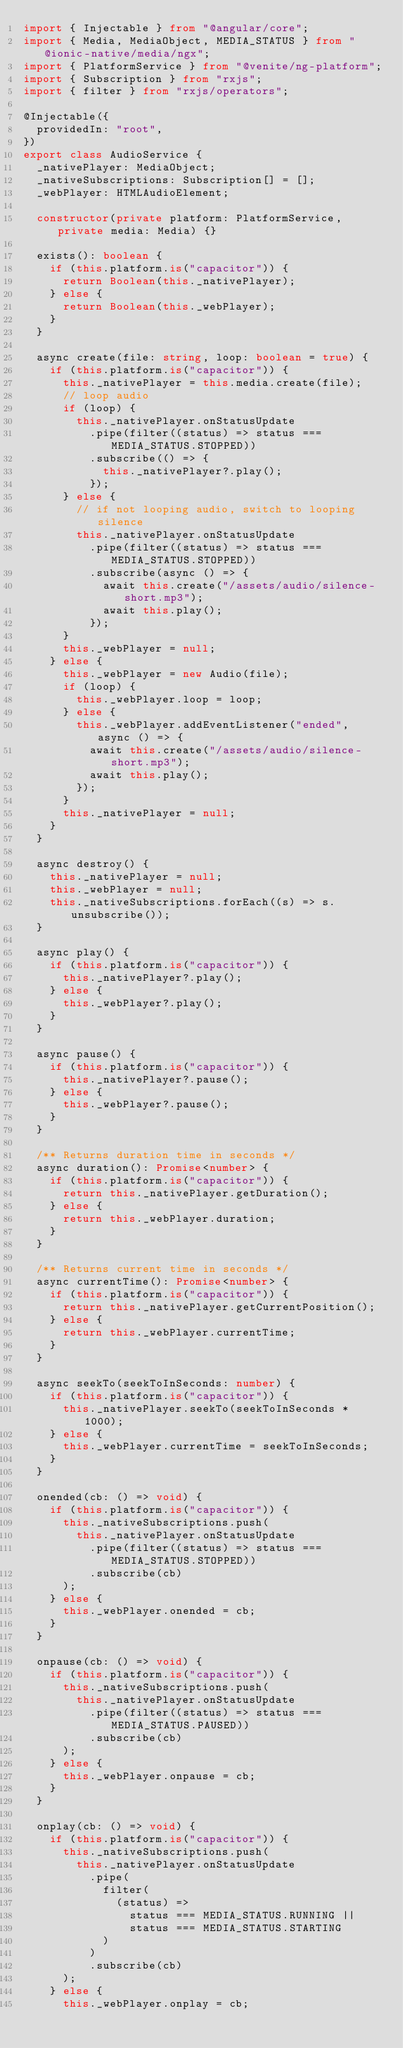Convert code to text. <code><loc_0><loc_0><loc_500><loc_500><_TypeScript_>import { Injectable } from "@angular/core";
import { Media, MediaObject, MEDIA_STATUS } from "@ionic-native/media/ngx";
import { PlatformService } from "@venite/ng-platform";
import { Subscription } from "rxjs";
import { filter } from "rxjs/operators";

@Injectable({
  providedIn: "root",
})
export class AudioService {
  _nativePlayer: MediaObject;
  _nativeSubscriptions: Subscription[] = [];
  _webPlayer: HTMLAudioElement;

  constructor(private platform: PlatformService, private media: Media) {}

  exists(): boolean {
    if (this.platform.is("capacitor")) {
      return Boolean(this._nativePlayer);
    } else {
      return Boolean(this._webPlayer);
    }
  }

  async create(file: string, loop: boolean = true) {
    if (this.platform.is("capacitor")) {
      this._nativePlayer = this.media.create(file);
      // loop audio
      if (loop) {
        this._nativePlayer.onStatusUpdate
          .pipe(filter((status) => status === MEDIA_STATUS.STOPPED))
          .subscribe(() => {
            this._nativePlayer?.play();
          });
      } else {
        // if not looping audio, switch to looping silence
        this._nativePlayer.onStatusUpdate
          .pipe(filter((status) => status === MEDIA_STATUS.STOPPED))
          .subscribe(async () => {
            await this.create("/assets/audio/silence-short.mp3");
            await this.play();
          });
      }
      this._webPlayer = null;
    } else {
      this._webPlayer = new Audio(file);
      if (loop) {
        this._webPlayer.loop = loop;
      } else {
        this._webPlayer.addEventListener("ended", async () => {
          await this.create("/assets/audio/silence-short.mp3");
          await this.play();
        });
      }
      this._nativePlayer = null;
    }
  }

  async destroy() {
    this._nativePlayer = null;
    this._webPlayer = null;
    this._nativeSubscriptions.forEach((s) => s.unsubscribe());
  }

  async play() {
    if (this.platform.is("capacitor")) {
      this._nativePlayer?.play();
    } else {
      this._webPlayer?.play();
    }
  }

  async pause() {
    if (this.platform.is("capacitor")) {
      this._nativePlayer?.pause();
    } else {
      this._webPlayer?.pause();
    }
  }

  /** Returns duration time in seconds */
  async duration(): Promise<number> {
    if (this.platform.is("capacitor")) {
      return this._nativePlayer.getDuration();
    } else {
      return this._webPlayer.duration;
    }
  }

  /** Returns current time in seconds */
  async currentTime(): Promise<number> {
    if (this.platform.is("capacitor")) {
      return this._nativePlayer.getCurrentPosition();
    } else {
      return this._webPlayer.currentTime;
    }
  }

  async seekTo(seekToInSeconds: number) {
    if (this.platform.is("capacitor")) {
      this._nativePlayer.seekTo(seekToInSeconds * 1000);
    } else {
      this._webPlayer.currentTime = seekToInSeconds;
    }
  }

  onended(cb: () => void) {
    if (this.platform.is("capacitor")) {
      this._nativeSubscriptions.push(
        this._nativePlayer.onStatusUpdate
          .pipe(filter((status) => status === MEDIA_STATUS.STOPPED))
          .subscribe(cb)
      );
    } else {
      this._webPlayer.onended = cb;
    }
  }

  onpause(cb: () => void) {
    if (this.platform.is("capacitor")) {
      this._nativeSubscriptions.push(
        this._nativePlayer.onStatusUpdate
          .pipe(filter((status) => status === MEDIA_STATUS.PAUSED))
          .subscribe(cb)
      );
    } else {
      this._webPlayer.onpause = cb;
    }
  }

  onplay(cb: () => void) {
    if (this.platform.is("capacitor")) {
      this._nativeSubscriptions.push(
        this._nativePlayer.onStatusUpdate
          .pipe(
            filter(
              (status) =>
                status === MEDIA_STATUS.RUNNING ||
                status === MEDIA_STATUS.STARTING
            )
          )
          .subscribe(cb)
      );
    } else {
      this._webPlayer.onplay = cb;</code> 